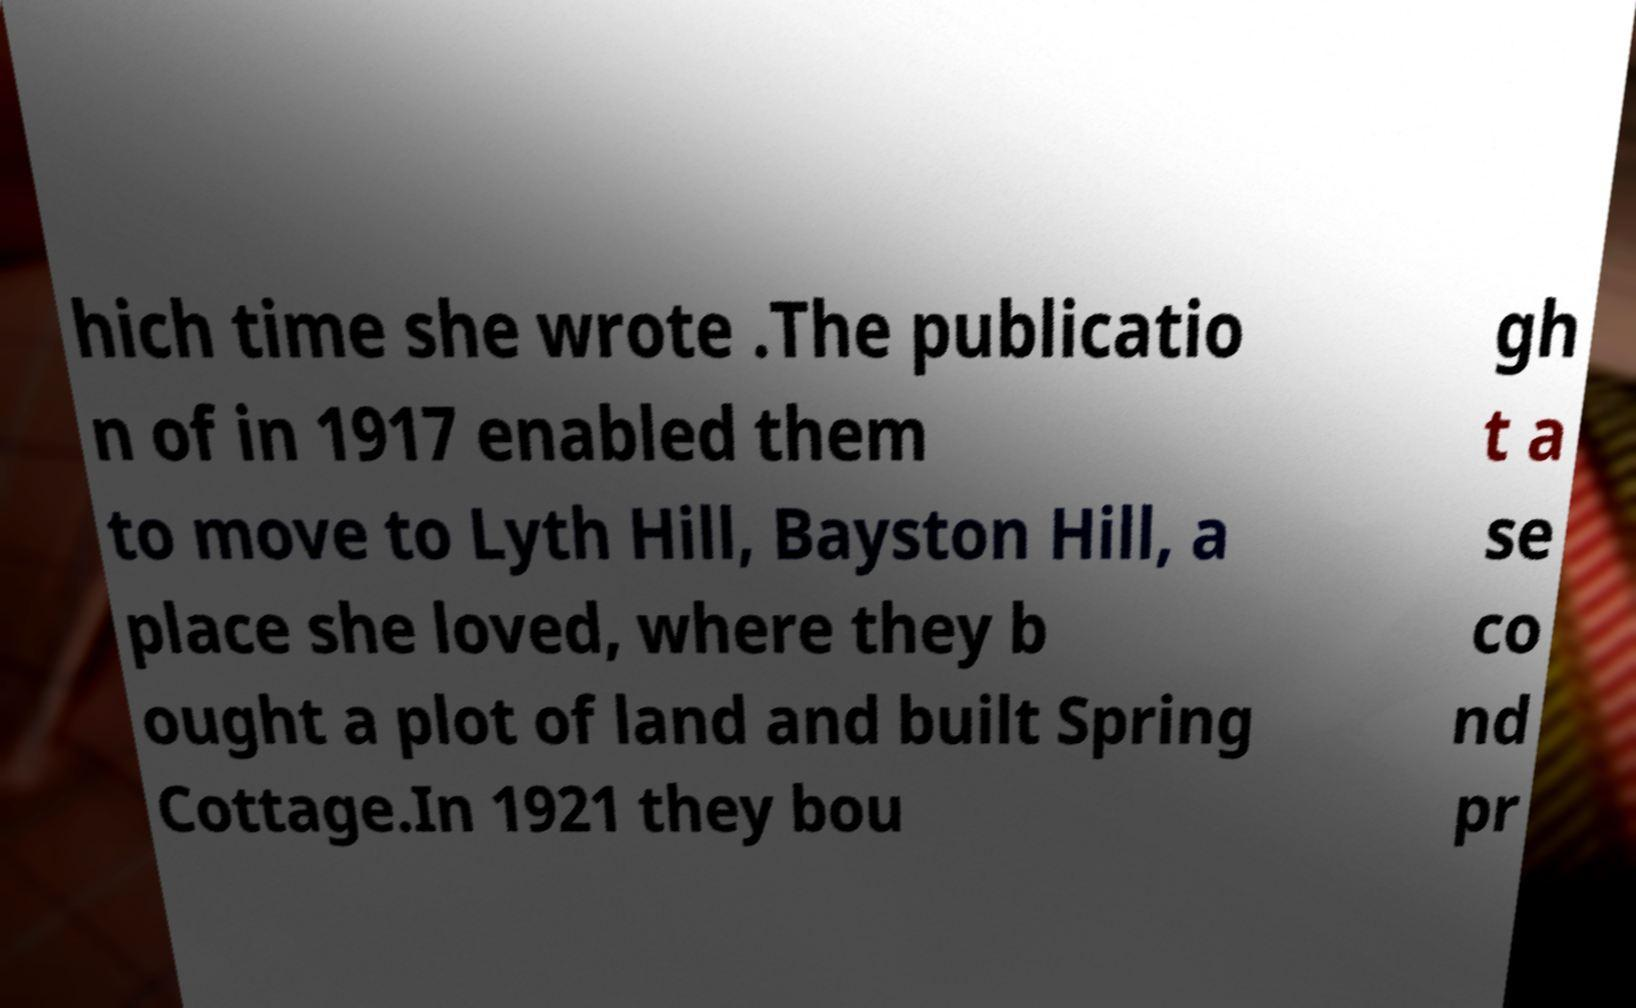Please identify and transcribe the text found in this image. hich time she wrote .The publicatio n of in 1917 enabled them to move to Lyth Hill, Bayston Hill, a place she loved, where they b ought a plot of land and built Spring Cottage.In 1921 they bou gh t a se co nd pr 